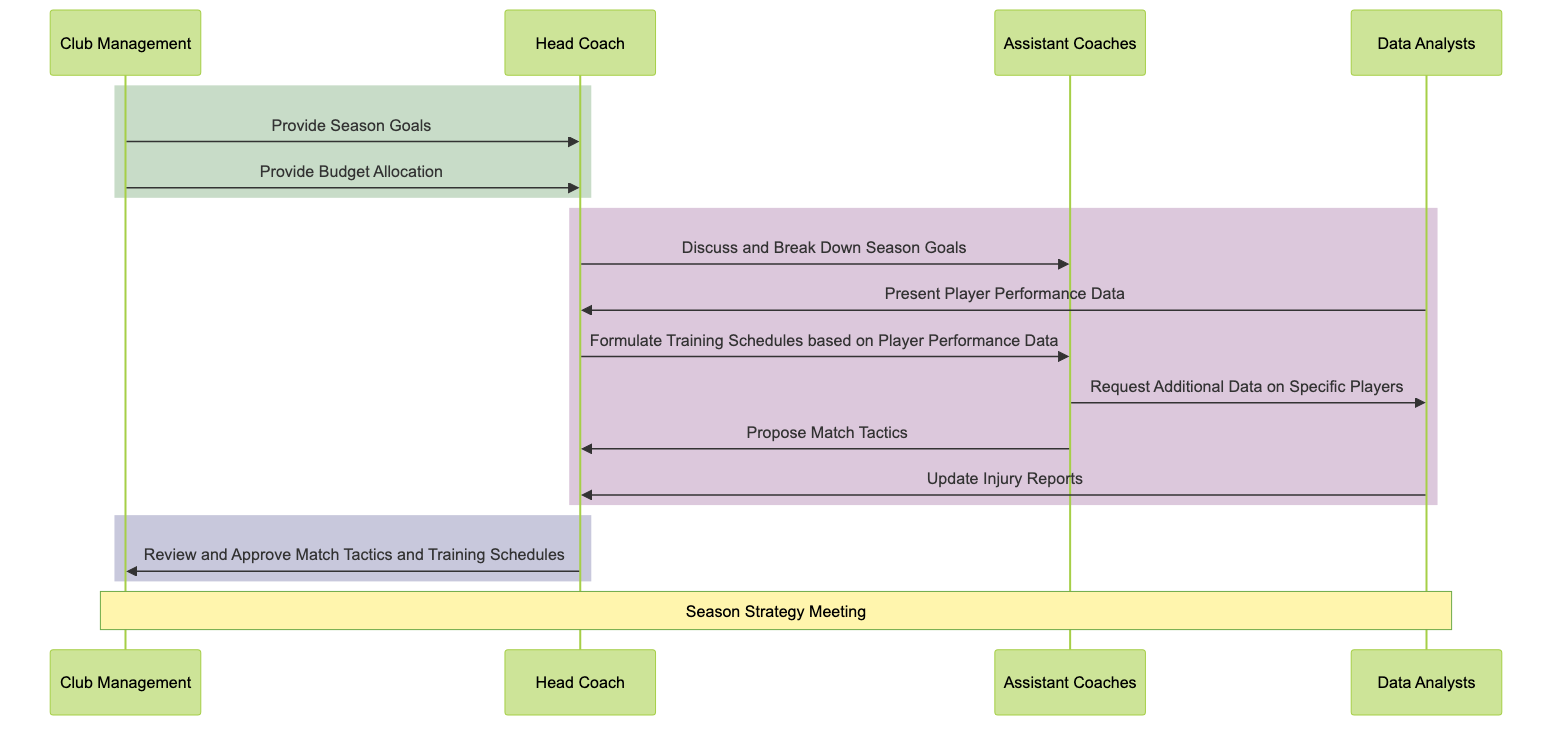What is the first interaction that takes place in the diagram? The first interaction occurs between Club Management and the Head Coach, where Club Management provides the Season Goals.
Answer: Provide Season Goals How many actors are represented in the diagram? The diagram features four actors: Club Management, Head Coach, Assistant Coaches, and Data Analysts.
Answer: Four Which actor proposes match tactics? The Assistant Coaches propose the match tactics.
Answer: Assistant Coaches What does Data Analysts present to the Head Coach? Data Analysts present Player Performance Data to the Head Coach.
Answer: Player Performance Data What is the last action performed in the diagram? The last action is the Head Coach reviewing and approving the match tactics and training schedules.
Answer: Review and Approve Match Tactics and Training Schedules Why do Assistant Coaches request additional data? Assistant Coaches request additional data to gain more insights on specific players, which aids in formulating strategies.
Answer: Insights on specific players Which two actors receive Season Goals from Club Management? Club Management communicates Season Goals to the Head Coach, who will further discuss them with Assistant Coaches.
Answer: Head Coach, Assistant Coaches 